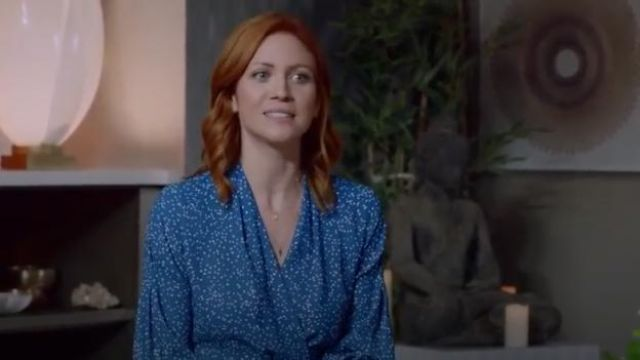What emotion does the expression of the subject convey in this scene? The expression of the woman in the image conveys a sense of contentment and calmness, highlighted by her gentle smile and relaxed posture. 